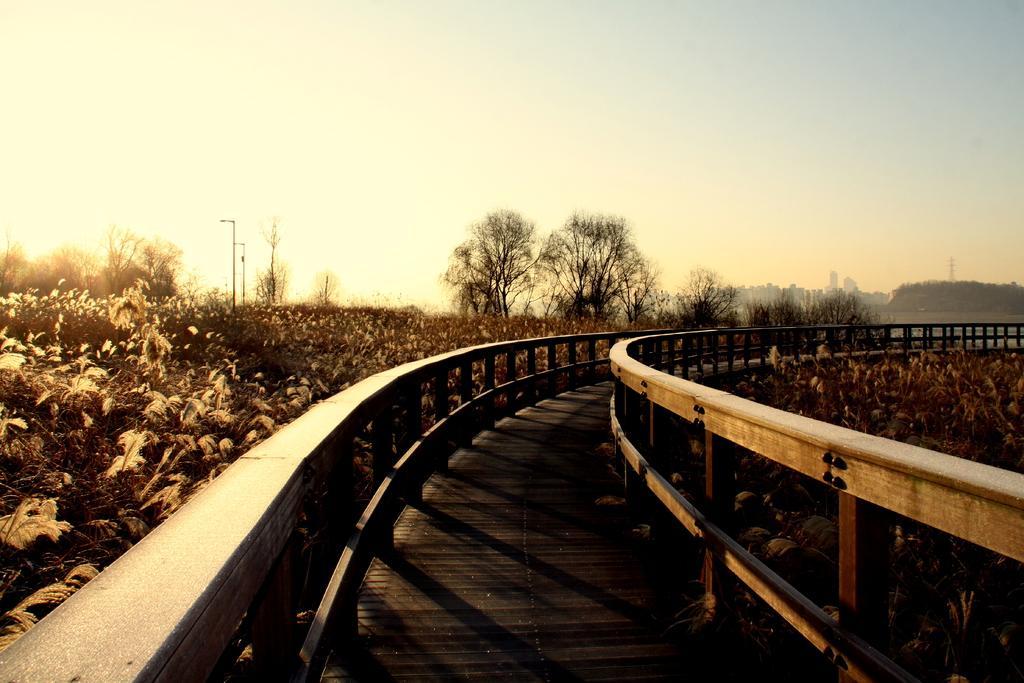In one or two sentences, can you explain what this image depicts? At the center of the image there is a path. On the left and right side of the path there is a wooden railing and plants. In the background there are trees, buildings and the sky. 